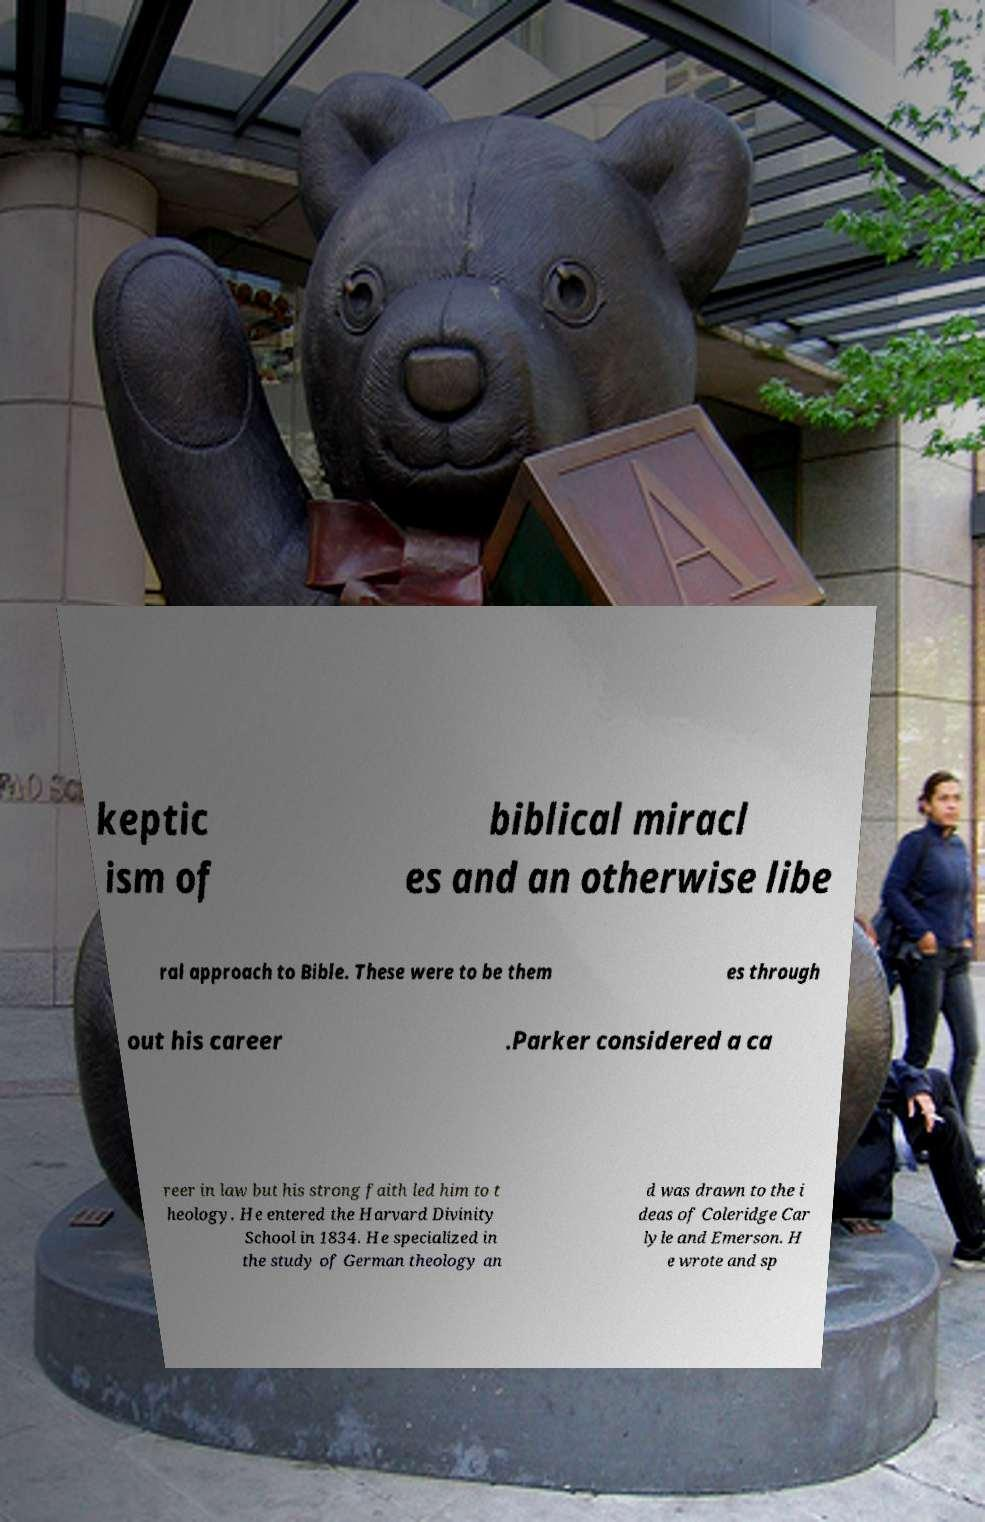Can you accurately transcribe the text from the provided image for me? keptic ism of biblical miracl es and an otherwise libe ral approach to Bible. These were to be them es through out his career .Parker considered a ca reer in law but his strong faith led him to t heology. He entered the Harvard Divinity School in 1834. He specialized in the study of German theology an d was drawn to the i deas of Coleridge Car lyle and Emerson. H e wrote and sp 